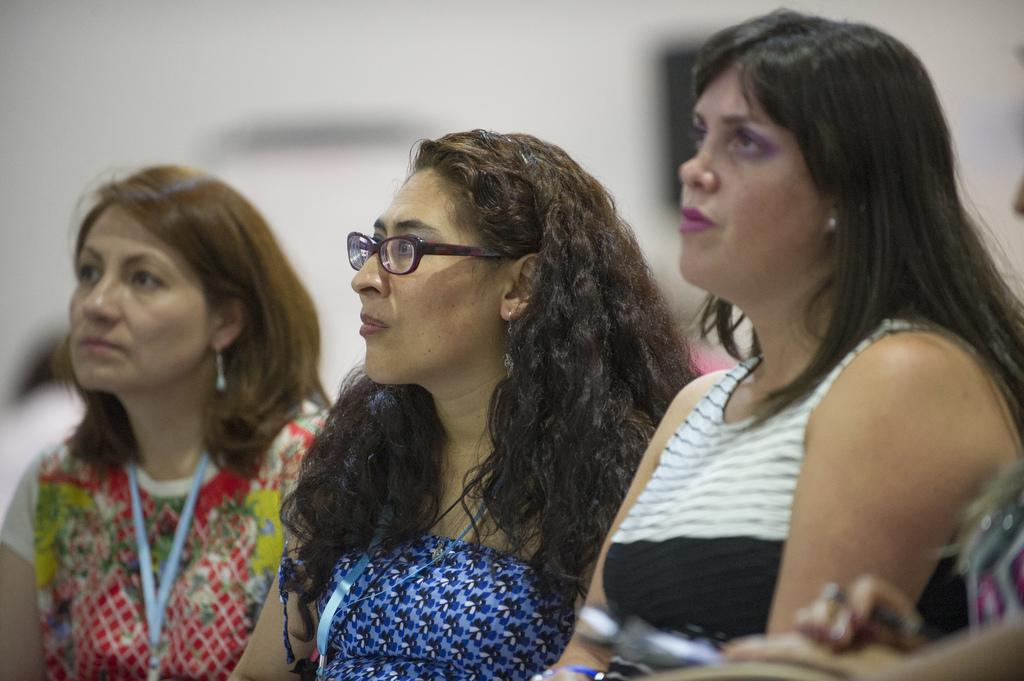How many women are in the image? There are three women in the image. What can be observed about the women's clothing? The women are wearing different color dresses. What is the color of the background in the image? The background of the image is white. What type of zipper can be seen on the women's dresses in the image? There is no zipper visible on the women's dresses in the image. What is the texture of the chin of the woman on the left in the image? There is no information about the texture of the women's chins in the image. 